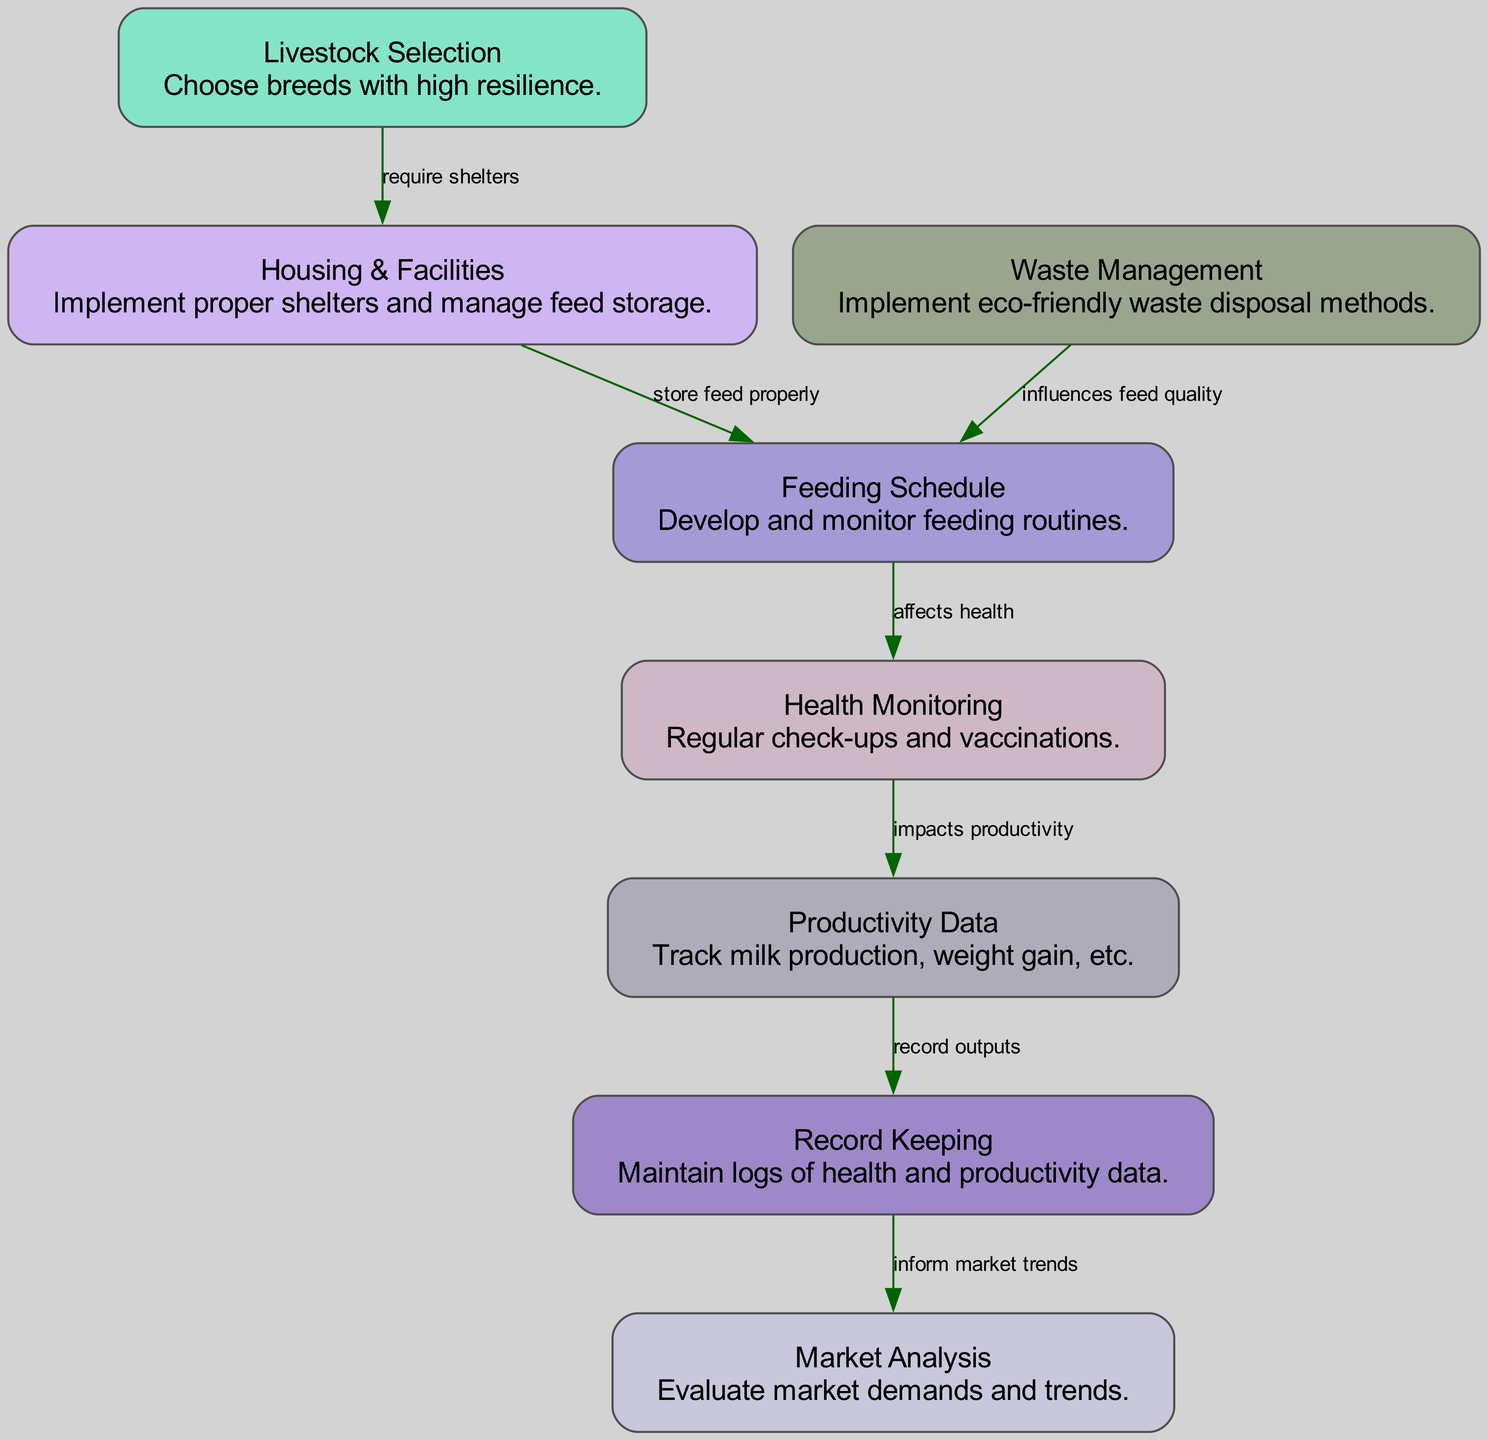What are the total number of nodes in the diagram? The diagram shows a total of 8 unique nodes, as listed in the data. These nodes represent different components of the livestock management cycle.
Answer: 8 Which node is connected to 'Health Monitoring'? 'Health Monitoring' is connected to 'Feeding Schedule', which influences it, and it in turn impacts 'Productivity Data'. Therefore, 'Feeding Schedule' is the node directly connected to 'Health Monitoring'.
Answer: Feeding Schedule What impact does 'Waste Management' have on 'Feeding Schedule'? According to the edge connecting these nodes, 'Waste Management' influences feed quality, which directly affects the 'Feeding Schedule'.
Answer: Influences feed quality Which nodes are involved in productivity tracking? The nodes involved in productivity tracking are 'Productivity Data' and 'Record Keeping', where 'Productivity Data' is recorded by 'Record Keeping' for effective tracking.
Answer: Productivity Data, Record Keeping How many edges are there connecting the nodes in the diagram? The diagram contains a total of 7 edges that connect the identified nodes, showing the relationships and influences among them.
Answer: 7 What is the relationship between 'Health Monitoring' and 'Productivity Data'? The diagram indicates that 'Health Monitoring' has a direct impact on 'Productivity Data', suggesting that the health of livestock affects their productivity levels.
Answer: Impacts productivity Which component is primarily responsible for evaluating market demands? The node that specifically handles evaluation of market demands and trends is the 'Market Analysis' node, which relies on the information from 'Record Keeping'.
Answer: Market Analysis What does 'Productivity Data' record? The description for 'Productivity Data' indicates it tracks outputs like milk production and weight gain. This is critical for assessing livestock performance.
Answer: Track milk production, weight gain, etc 